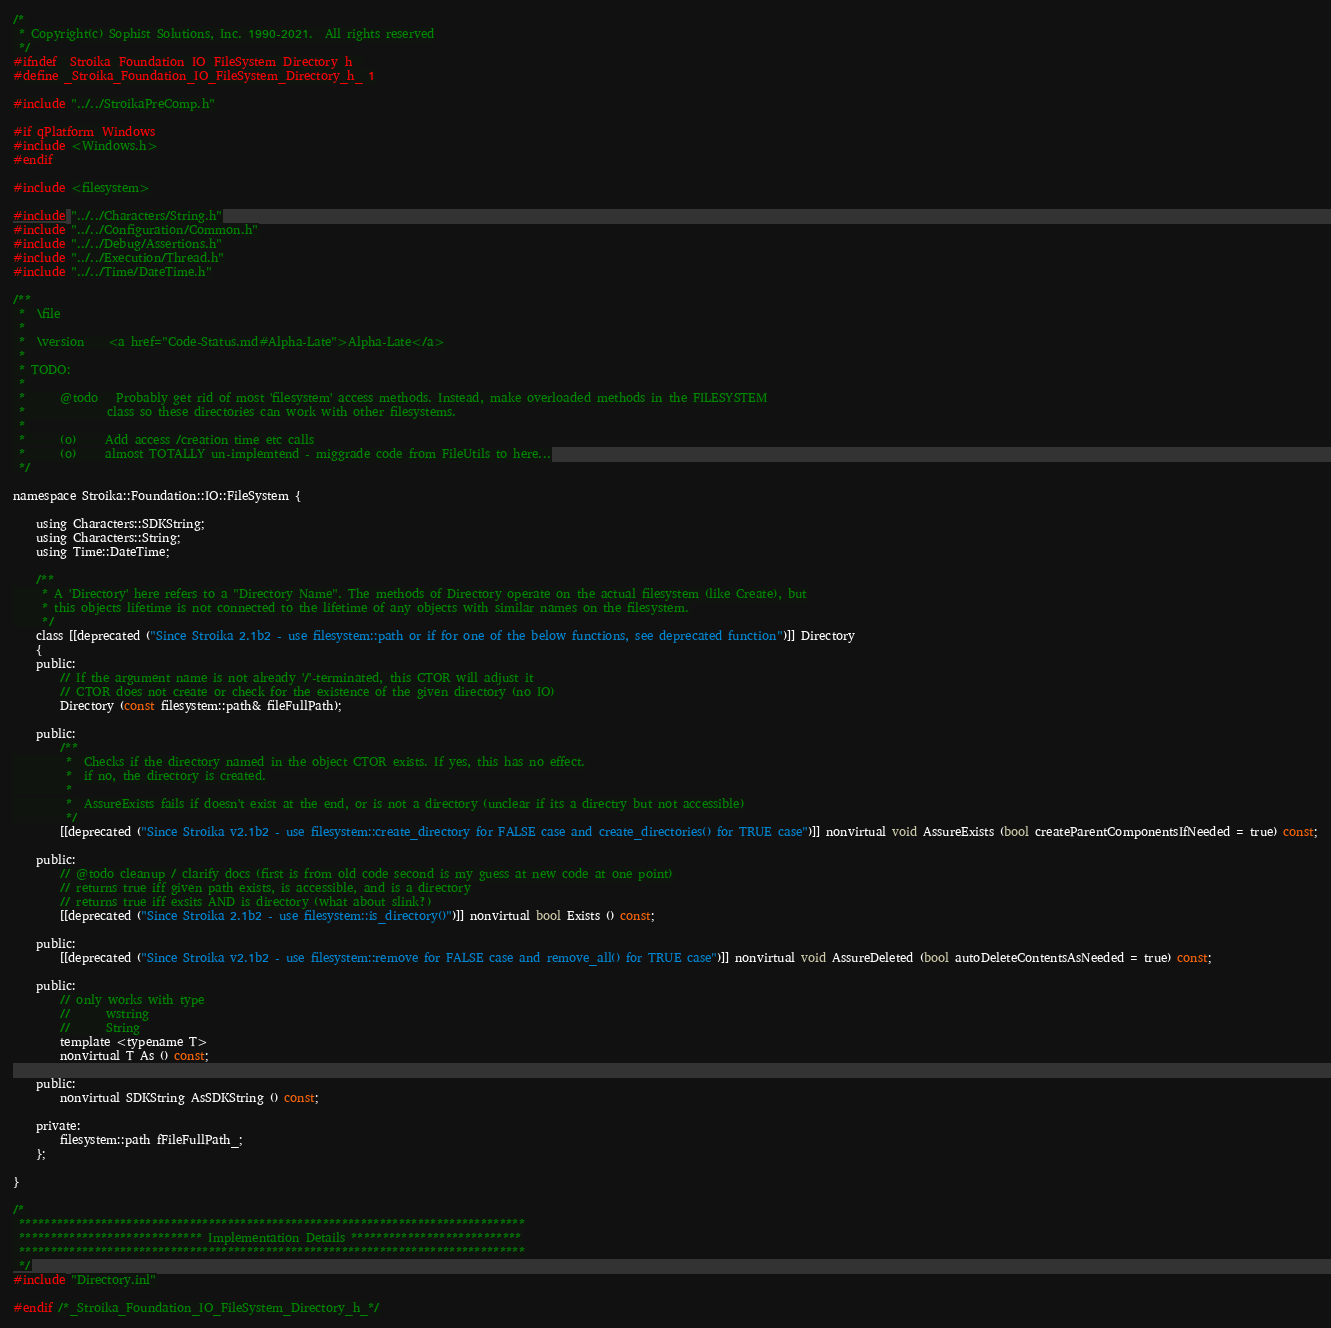Convert code to text. <code><loc_0><loc_0><loc_500><loc_500><_C_>/*
 * Copyright(c) Sophist Solutions, Inc. 1990-2021.  All rights reserved
 */
#ifndef _Stroika_Foundation_IO_FileSystem_Directory_h_
#define _Stroika_Foundation_IO_FileSystem_Directory_h_ 1

#include "../../StroikaPreComp.h"

#if qPlatform_Windows
#include <Windows.h>
#endif

#include <filesystem>

#include "../../Characters/String.h"
#include "../../Configuration/Common.h"
#include "../../Debug/Assertions.h"
#include "../../Execution/Thread.h"
#include "../../Time/DateTime.h"

/**
 *  \file
 *
 *  \version    <a href="Code-Status.md#Alpha-Late">Alpha-Late</a>
 *
 * TODO:
 *
 *      @todo   Probably get rid of most 'filesystem' access methods. Instead, make overloaded methods in the FILESYSTEM
 *              class so these directories can work with other filesystems.
 *
 *      (o)     Add access /creation time etc calls
 *      (o)     almost TOTALLY un-implemtend - miggrade code from FileUtils to here...
 */

namespace Stroika::Foundation::IO::FileSystem {

    using Characters::SDKString;
    using Characters::String;
    using Time::DateTime;

    /**
     * A 'Directory' here refers to a "Directory Name". The methods of Directory operate on the actual filesystem (like Create), but
     * this objects lifetime is not connected to the lifetime of any objects with similar names on the filesystem.
     */
    class [[deprecated ("Since Stroika 2.1b2 - use filesystem::path or if for one of the below functions, see deprecated function")]] Directory
    {
    public:
        // If the argument name is not already '/'-terminated, this CTOR will adjust it
        // CTOR does not create or check for the existence of the given directory (no IO)
        Directory (const filesystem::path& fileFullPath);

    public:
        /**
         *  Checks if the directory named in the object CTOR exists. If yes, this has no effect.
         *  if no, the directory is created.
         *
         *  AssureExists fails if doesn't exist at the end, or is not a directory (unclear if its a directry but not accessible)
         */
        [[deprecated ("Since Stroika v2.1b2 - use filesystem::create_directory for FALSE case and create_directories() for TRUE case")]] nonvirtual void AssureExists (bool createParentComponentsIfNeeded = true) const;

    public:
        // @todo cleanup / clarify docs (first is from old code second is my guess at new code at one point)
        // returns true iff given path exists, is accessible, and is a directory
        // returns true iff exsits AND is directory (what about slink?)
        [[deprecated ("Since Stroika 2.1b2 - use filesystem::is_directory()")]] nonvirtual bool Exists () const;

    public:
        [[deprecated ("Since Stroika v2.1b2 - use filesystem::remove for FALSE case and remove_all() for TRUE case")]] nonvirtual void AssureDeleted (bool autoDeleteContentsAsNeeded = true) const;

    public:
        // only works with type
        //      wstring
        //      String
        template <typename T>
        nonvirtual T As () const;

    public:
        nonvirtual SDKString AsSDKString () const;

    private:
        filesystem::path fFileFullPath_;
    };

}

/*
 ********************************************************************************
 ***************************** Implementation Details ***************************
 ********************************************************************************
 */
#include "Directory.inl"

#endif /*_Stroika_Foundation_IO_FileSystem_Directory_h_*/
</code> 